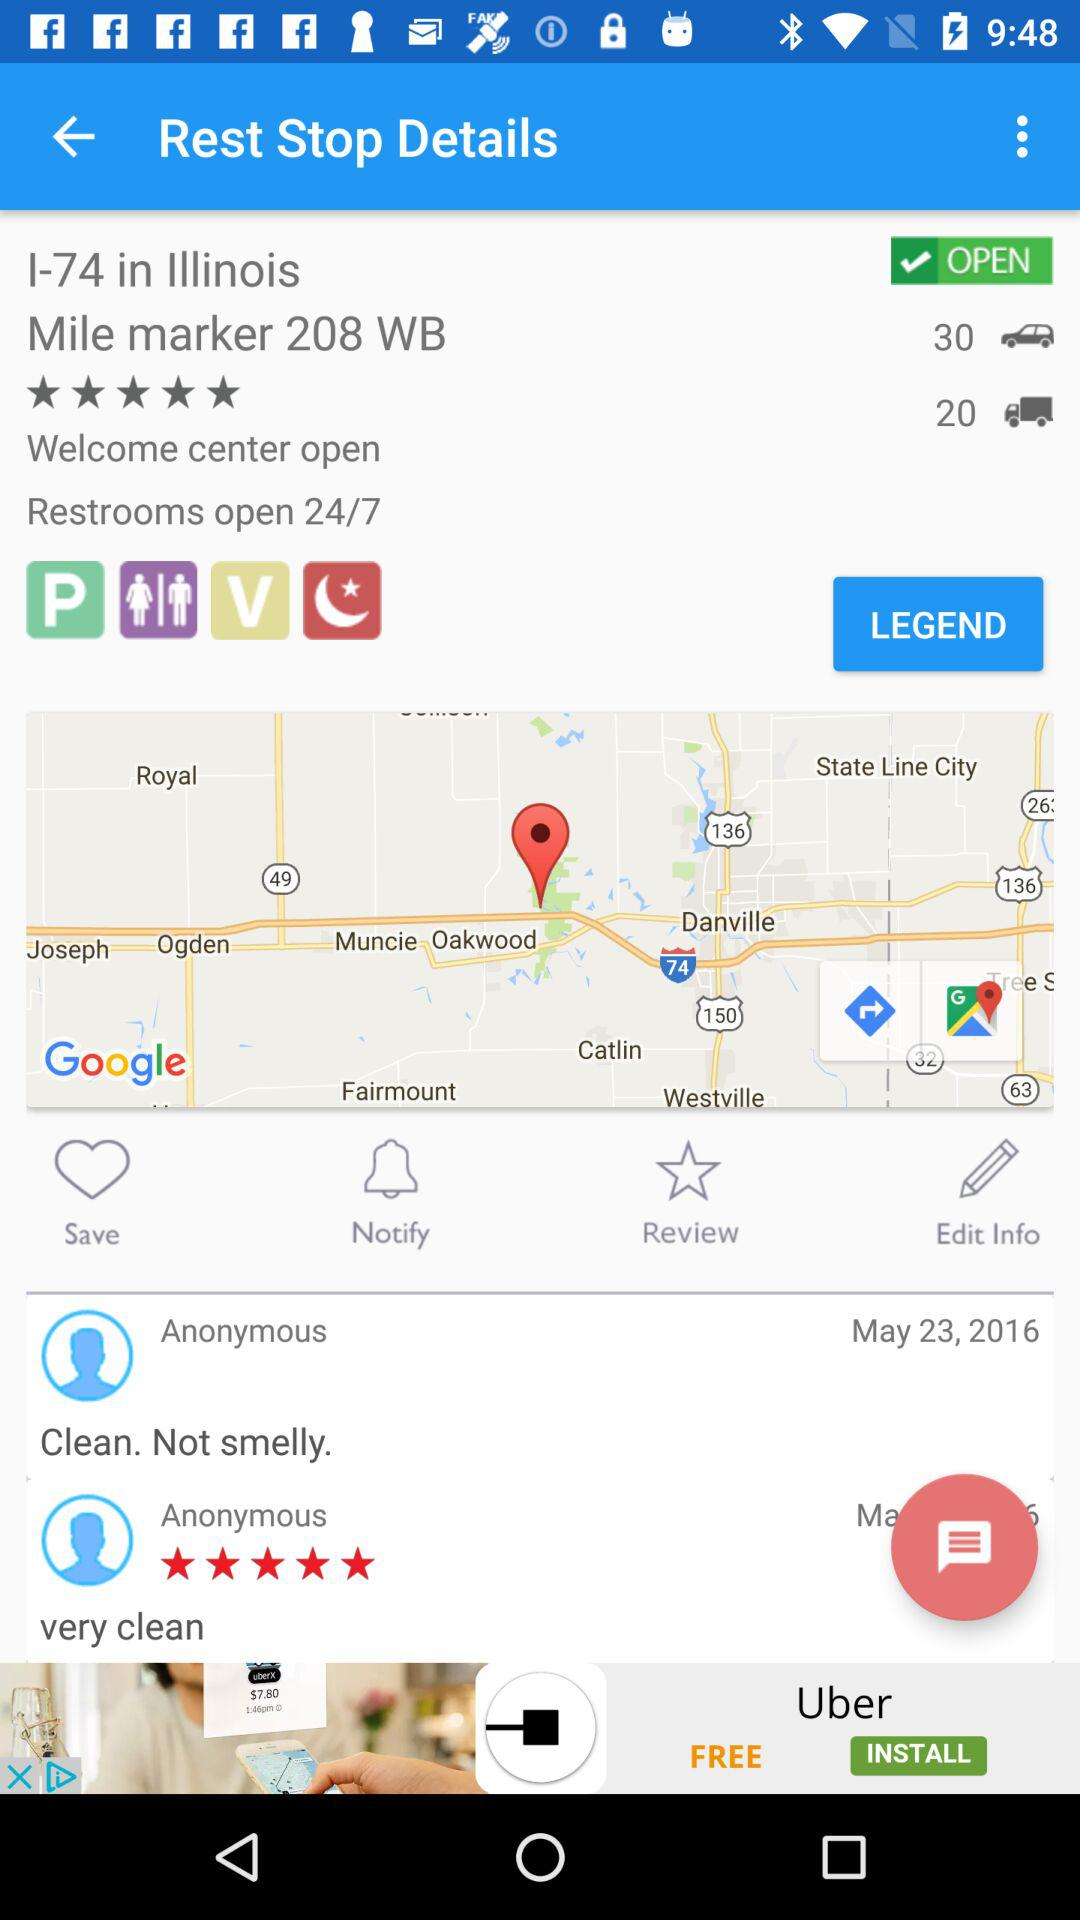What is the star rating of the review very clean? The rating of the review very clean is 5 stars. 